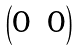<formula> <loc_0><loc_0><loc_500><loc_500>\begin{pmatrix} 0 & 0 \end{pmatrix}</formula> 